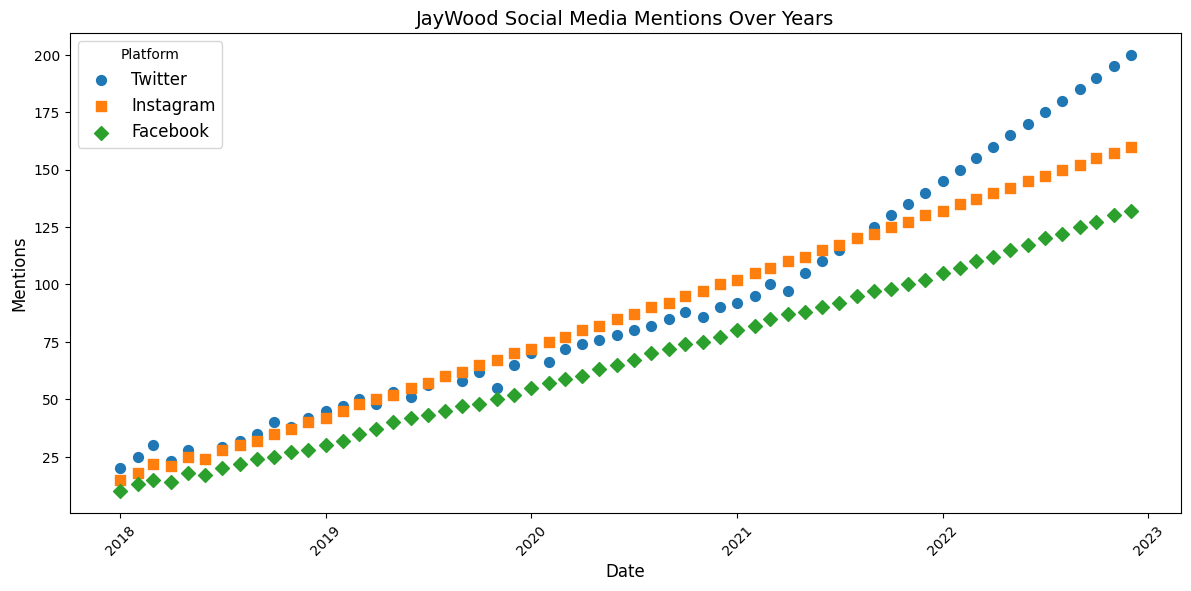What is the general trend of JayWood's mentions on Twitter from 2018 to 2022? Observing the scatter plot, the mentions on Twitter generally show an upward trend from 2018 to 2022. The points representing Twitter mentions rise consistently throughout these years.
Answer: Increasing Which platform had the highest mentions in December 2018? Look at the scatter plot for December 2018 and compare mentions across platforms. Twitter, Instagram, and Facebook have 42, 40, and 28 mentions, respectively.
Answer: Twitter How do the mentions on Instagram in January 2020 compare to those on Facebook in the same month? The scatter plot shows that Instagram had 72 mentions and Facebook had 55 mentions in January 2020. Comparing these values, Instagram had more mentions.
Answer: Instagram had more mentions Identify two months where the mentions on Facebook were the same. Look for points on the scatter plot that align in the same horizontal position for Facebook. For instance, January 2021 and February 2021 where both have 82 mentions.
Answer: January 2021 and February 2021 What was the average number of mentions on Twitter in 2019? To find the average, add up all the monthly mentions for Twitter in 2019 (45+47+50+48+53+51+56+60+58+62+55+65 = 650), then divide by 12.
Answer: (650/12) = 54.17 Which platform shows the steepest increase in mentions over the years? Compare the slope of the points for each platform over the years. Twitter shows the steepest upward slope from 20 mentions in January 2018 to 200 mentions in December 2022.
Answer: Twitter During which year did Instagram see the highest relative increase in mentions? For Instagram, calculate the difference in mentions between the start and end months for each year. The highest relative increase appears to be in 2019 where the mentions increased from 40 in December 2018 to 70 in December 2019 (increase of 30).
Answer: 2019 Comparing the mentions in July 2020 and December 2022, by how much did the mentions increase on Facebook? From July 2020, 67 mentions to December 2022, 132 mentions, an increase of 132 - 67.
Answer: 65 mentions Which platform had the least variation in mentions during 2020? Look at the range of mentions for each platform in 2020. Twitter ranges from 70-90, Instagram from 72-100, and Facebook from 55-77. Facebook has the least variation.
Answer: Facebook What can be inferred about JayWood's popularity on social media from 2018 to 2022? The scatter plot shows an overall increasing trend in mentions across all platforms from 2018 to 2022, indicating growing popularity.
Answer: Increasing popularity across all platforms 